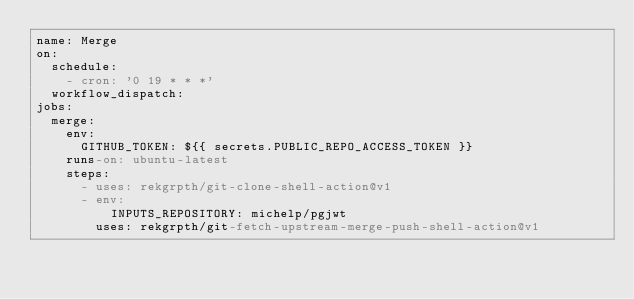Convert code to text. <code><loc_0><loc_0><loc_500><loc_500><_YAML_>name: Merge
on:
  schedule:
    - cron: '0 19 * * *'
  workflow_dispatch:
jobs:
  merge:
    env:
      GITHUB_TOKEN: ${{ secrets.PUBLIC_REPO_ACCESS_TOKEN }}
    runs-on: ubuntu-latest
    steps:
      - uses: rekgrpth/git-clone-shell-action@v1
      - env:
          INPUTS_REPOSITORY: michelp/pgjwt
        uses: rekgrpth/git-fetch-upstream-merge-push-shell-action@v1
</code> 